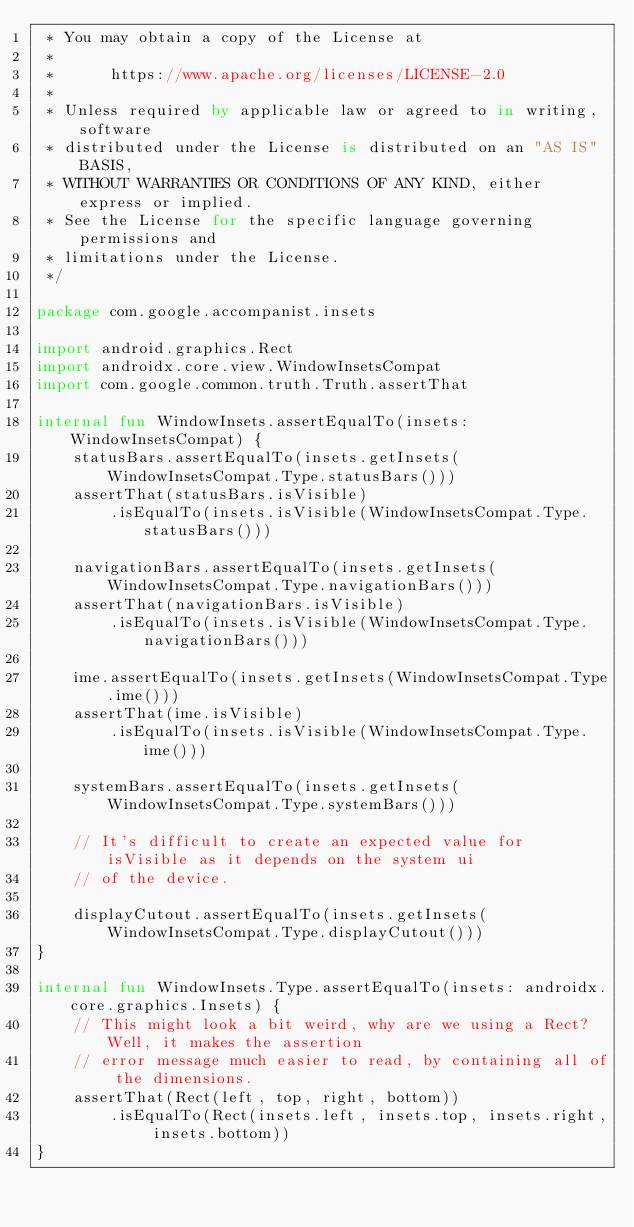<code> <loc_0><loc_0><loc_500><loc_500><_Kotlin_> * You may obtain a copy of the License at
 *
 *      https://www.apache.org/licenses/LICENSE-2.0
 *
 * Unless required by applicable law or agreed to in writing, software
 * distributed under the License is distributed on an "AS IS" BASIS,
 * WITHOUT WARRANTIES OR CONDITIONS OF ANY KIND, either express or implied.
 * See the License for the specific language governing permissions and
 * limitations under the License.
 */

package com.google.accompanist.insets

import android.graphics.Rect
import androidx.core.view.WindowInsetsCompat
import com.google.common.truth.Truth.assertThat

internal fun WindowInsets.assertEqualTo(insets: WindowInsetsCompat) {
    statusBars.assertEqualTo(insets.getInsets(WindowInsetsCompat.Type.statusBars()))
    assertThat(statusBars.isVisible)
        .isEqualTo(insets.isVisible(WindowInsetsCompat.Type.statusBars()))

    navigationBars.assertEqualTo(insets.getInsets(WindowInsetsCompat.Type.navigationBars()))
    assertThat(navigationBars.isVisible)
        .isEqualTo(insets.isVisible(WindowInsetsCompat.Type.navigationBars()))

    ime.assertEqualTo(insets.getInsets(WindowInsetsCompat.Type.ime()))
    assertThat(ime.isVisible)
        .isEqualTo(insets.isVisible(WindowInsetsCompat.Type.ime()))

    systemBars.assertEqualTo(insets.getInsets(WindowInsetsCompat.Type.systemBars()))

    // It's difficult to create an expected value for isVisible as it depends on the system ui
    // of the device.

    displayCutout.assertEqualTo(insets.getInsets(WindowInsetsCompat.Type.displayCutout()))
}

internal fun WindowInsets.Type.assertEqualTo(insets: androidx.core.graphics.Insets) {
    // This might look a bit weird, why are we using a Rect? Well, it makes the assertion
    // error message much easier to read, by containing all of the dimensions.
    assertThat(Rect(left, top, right, bottom))
        .isEqualTo(Rect(insets.left, insets.top, insets.right, insets.bottom))
}
</code> 